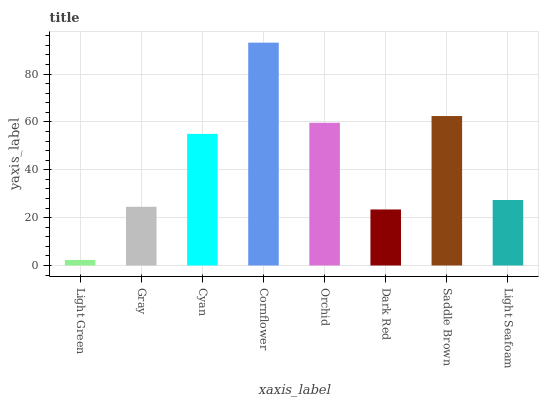Is Light Green the minimum?
Answer yes or no. Yes. Is Cornflower the maximum?
Answer yes or no. Yes. Is Gray the minimum?
Answer yes or no. No. Is Gray the maximum?
Answer yes or no. No. Is Gray greater than Light Green?
Answer yes or no. Yes. Is Light Green less than Gray?
Answer yes or no. Yes. Is Light Green greater than Gray?
Answer yes or no. No. Is Gray less than Light Green?
Answer yes or no. No. Is Cyan the high median?
Answer yes or no. Yes. Is Light Seafoam the low median?
Answer yes or no. Yes. Is Gray the high median?
Answer yes or no. No. Is Cornflower the low median?
Answer yes or no. No. 